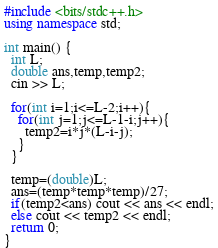Convert code to text. <code><loc_0><loc_0><loc_500><loc_500><_C++_>#include <bits/stdc++.h>
using namespace std;

int main() {
  int L;
  double ans,temp,temp2;
  cin >> L;
  
  for(int i=1;i<=L-2;i++){
    for(int j=1;j<=L-1-i;j++){
      temp2=i*j*(L-i-j);
    }
  }
  
  temp=(double)L;
  ans=(temp*temp*temp)/27;
  if(temp2<ans) cout << ans << endl;
  else cout << temp2 << endl;
  return 0;
}
</code> 